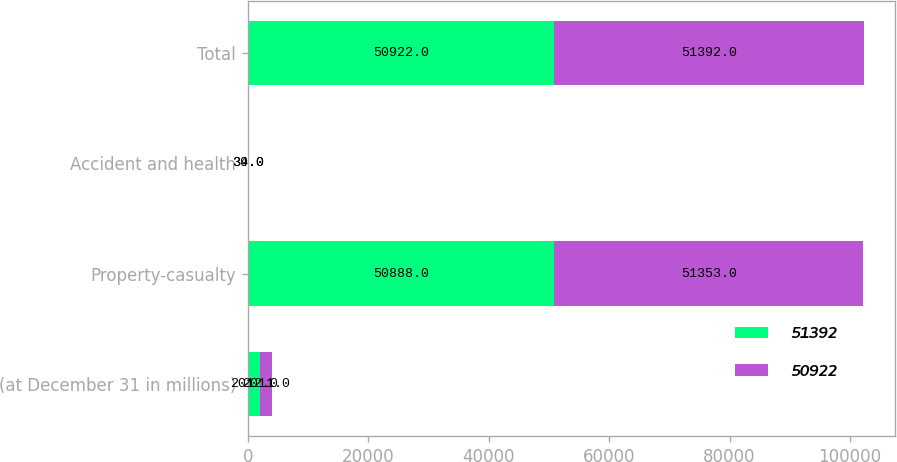<chart> <loc_0><loc_0><loc_500><loc_500><stacked_bar_chart><ecel><fcel>(at December 31 in millions)<fcel>Property-casualty<fcel>Accident and health<fcel>Total<nl><fcel>51392<fcel>2012<fcel>50888<fcel>34<fcel>50922<nl><fcel>50922<fcel>2011<fcel>51353<fcel>39<fcel>51392<nl></chart> 